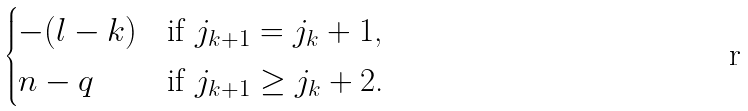Convert formula to latex. <formula><loc_0><loc_0><loc_500><loc_500>\begin{cases} - ( l - k ) & \text {if $j_{k+1} =j_{k}+1$,} \\ n - q & \text {if $j_{k+1} \geq j_{k} + 2$.} \end{cases}</formula> 